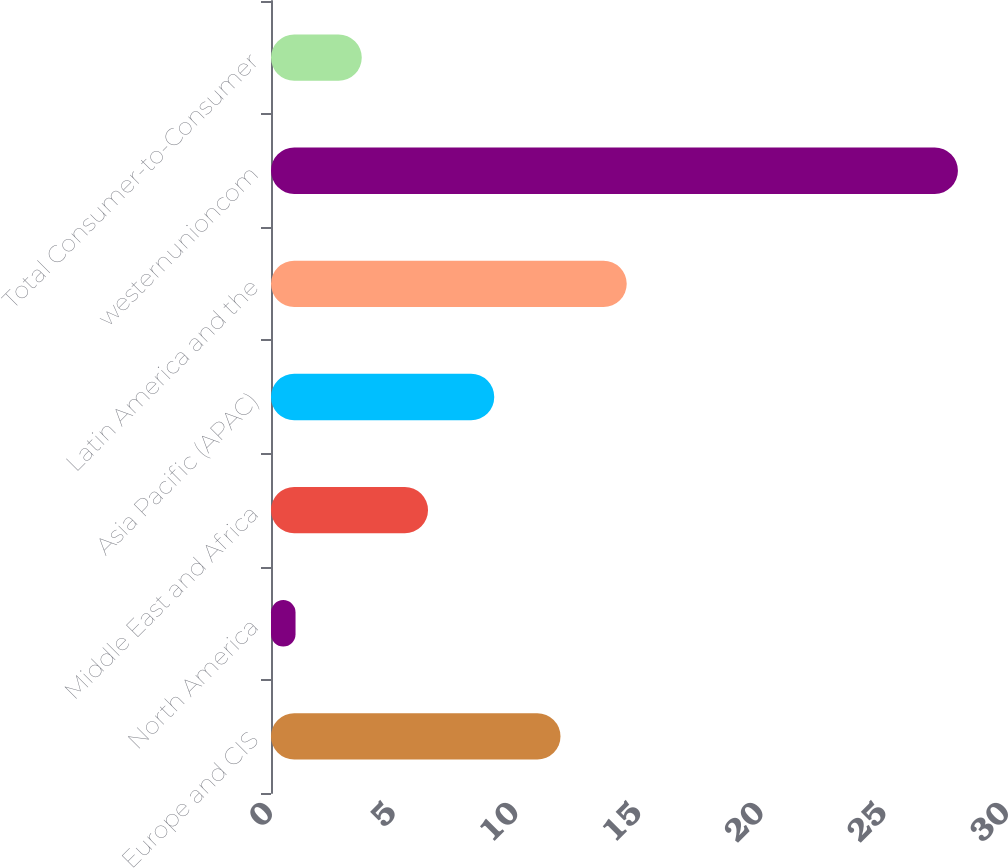Convert chart to OTSL. <chart><loc_0><loc_0><loc_500><loc_500><bar_chart><fcel>Europe and CIS<fcel>North America<fcel>Middle East and Africa<fcel>Asia Pacific (APAC)<fcel>Latin America and the<fcel>westernunioncom<fcel>Total Consumer-to-Consumer<nl><fcel>11.8<fcel>1<fcel>6.4<fcel>9.1<fcel>14.5<fcel>28<fcel>3.7<nl></chart> 